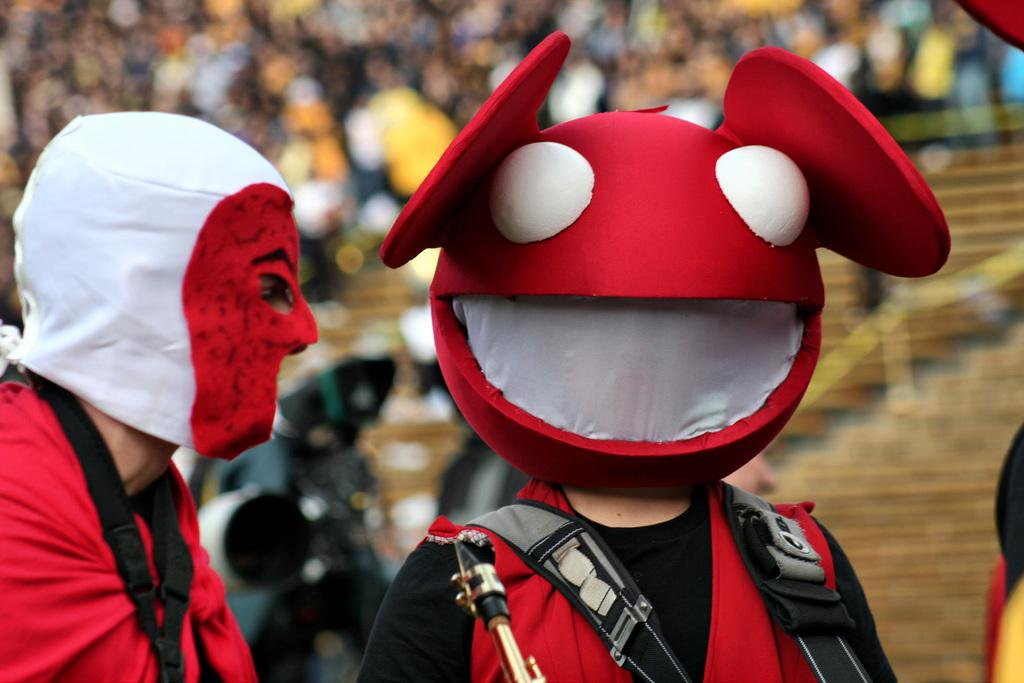How many people are in the image? There are two people in the image. What are the people wearing? The people are wearing costumes. What can be seen in front of the people? There is an object in front of the people. Can you describe the background of the image? The background of the image is blurry. How many houses can be seen in the background of the image? There are no houses visible in the background of the image; it is blurry. What type of operation is being performed by the people in the image? There is no operation being performed by the people in the image; they are simply wearing costumes. 